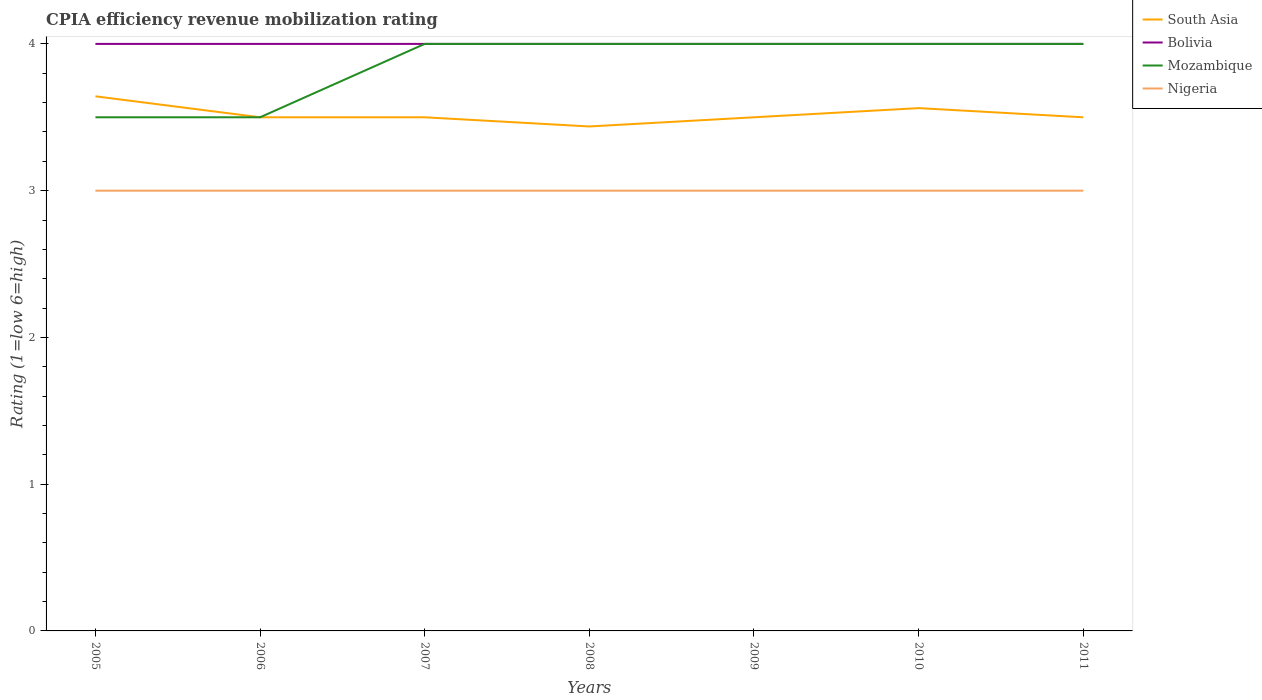How many different coloured lines are there?
Ensure brevity in your answer.  4. Does the line corresponding to Nigeria intersect with the line corresponding to South Asia?
Your answer should be compact. No. Across all years, what is the maximum CPIA rating in South Asia?
Offer a very short reply. 3.44. In which year was the CPIA rating in South Asia maximum?
Offer a very short reply. 2008. What is the total CPIA rating in South Asia in the graph?
Ensure brevity in your answer.  0.08. What is the difference between the highest and the second highest CPIA rating in Bolivia?
Keep it short and to the point. 0. How many lines are there?
Keep it short and to the point. 4. How many years are there in the graph?
Keep it short and to the point. 7. Are the values on the major ticks of Y-axis written in scientific E-notation?
Your answer should be very brief. No. Does the graph contain grids?
Keep it short and to the point. No. Where does the legend appear in the graph?
Provide a short and direct response. Top right. How many legend labels are there?
Give a very brief answer. 4. How are the legend labels stacked?
Give a very brief answer. Vertical. What is the title of the graph?
Ensure brevity in your answer.  CPIA efficiency revenue mobilization rating. What is the label or title of the X-axis?
Offer a very short reply. Years. What is the Rating (1=low 6=high) in South Asia in 2005?
Offer a very short reply. 3.64. What is the Rating (1=low 6=high) of Mozambique in 2005?
Offer a very short reply. 3.5. What is the Rating (1=low 6=high) of Nigeria in 2006?
Ensure brevity in your answer.  3. What is the Rating (1=low 6=high) of Bolivia in 2007?
Offer a very short reply. 4. What is the Rating (1=low 6=high) in Mozambique in 2007?
Make the answer very short. 4. What is the Rating (1=low 6=high) in South Asia in 2008?
Give a very brief answer. 3.44. What is the Rating (1=low 6=high) of Mozambique in 2008?
Offer a terse response. 4. What is the Rating (1=low 6=high) of Nigeria in 2008?
Give a very brief answer. 3. What is the Rating (1=low 6=high) in Bolivia in 2009?
Keep it short and to the point. 4. What is the Rating (1=low 6=high) in Nigeria in 2009?
Offer a terse response. 3. What is the Rating (1=low 6=high) in South Asia in 2010?
Your answer should be compact. 3.56. What is the Rating (1=low 6=high) in Mozambique in 2010?
Provide a short and direct response. 4. What is the Rating (1=low 6=high) of South Asia in 2011?
Give a very brief answer. 3.5. What is the Rating (1=low 6=high) of Bolivia in 2011?
Make the answer very short. 4. What is the Rating (1=low 6=high) of Mozambique in 2011?
Provide a short and direct response. 4. What is the Rating (1=low 6=high) in Nigeria in 2011?
Give a very brief answer. 3. Across all years, what is the maximum Rating (1=low 6=high) of South Asia?
Ensure brevity in your answer.  3.64. Across all years, what is the maximum Rating (1=low 6=high) of Bolivia?
Provide a short and direct response. 4. Across all years, what is the maximum Rating (1=low 6=high) in Mozambique?
Your answer should be very brief. 4. Across all years, what is the minimum Rating (1=low 6=high) of South Asia?
Ensure brevity in your answer.  3.44. Across all years, what is the minimum Rating (1=low 6=high) in Bolivia?
Your answer should be very brief. 4. Across all years, what is the minimum Rating (1=low 6=high) in Mozambique?
Your answer should be compact. 3.5. Across all years, what is the minimum Rating (1=low 6=high) in Nigeria?
Ensure brevity in your answer.  3. What is the total Rating (1=low 6=high) of South Asia in the graph?
Provide a short and direct response. 24.64. What is the difference between the Rating (1=low 6=high) of South Asia in 2005 and that in 2006?
Give a very brief answer. 0.14. What is the difference between the Rating (1=low 6=high) in Nigeria in 2005 and that in 2006?
Ensure brevity in your answer.  0. What is the difference between the Rating (1=low 6=high) of South Asia in 2005 and that in 2007?
Provide a short and direct response. 0.14. What is the difference between the Rating (1=low 6=high) in Mozambique in 2005 and that in 2007?
Your answer should be compact. -0.5. What is the difference between the Rating (1=low 6=high) of South Asia in 2005 and that in 2008?
Your answer should be compact. 0.21. What is the difference between the Rating (1=low 6=high) of Bolivia in 2005 and that in 2008?
Provide a short and direct response. 0. What is the difference between the Rating (1=low 6=high) in Nigeria in 2005 and that in 2008?
Your answer should be very brief. 0. What is the difference between the Rating (1=low 6=high) of South Asia in 2005 and that in 2009?
Give a very brief answer. 0.14. What is the difference between the Rating (1=low 6=high) of Bolivia in 2005 and that in 2009?
Provide a short and direct response. 0. What is the difference between the Rating (1=low 6=high) of South Asia in 2005 and that in 2010?
Offer a very short reply. 0.08. What is the difference between the Rating (1=low 6=high) of Bolivia in 2005 and that in 2010?
Provide a succinct answer. 0. What is the difference between the Rating (1=low 6=high) of Nigeria in 2005 and that in 2010?
Make the answer very short. 0. What is the difference between the Rating (1=low 6=high) in South Asia in 2005 and that in 2011?
Provide a succinct answer. 0.14. What is the difference between the Rating (1=low 6=high) of Bolivia in 2005 and that in 2011?
Make the answer very short. 0. What is the difference between the Rating (1=low 6=high) in Nigeria in 2005 and that in 2011?
Give a very brief answer. 0. What is the difference between the Rating (1=low 6=high) in South Asia in 2006 and that in 2007?
Your response must be concise. 0. What is the difference between the Rating (1=low 6=high) in South Asia in 2006 and that in 2008?
Provide a succinct answer. 0.06. What is the difference between the Rating (1=low 6=high) in Bolivia in 2006 and that in 2008?
Ensure brevity in your answer.  0. What is the difference between the Rating (1=low 6=high) in South Asia in 2006 and that in 2009?
Your response must be concise. 0. What is the difference between the Rating (1=low 6=high) in Bolivia in 2006 and that in 2009?
Give a very brief answer. 0. What is the difference between the Rating (1=low 6=high) in Nigeria in 2006 and that in 2009?
Your response must be concise. 0. What is the difference between the Rating (1=low 6=high) of South Asia in 2006 and that in 2010?
Your answer should be compact. -0.06. What is the difference between the Rating (1=low 6=high) of Mozambique in 2006 and that in 2010?
Provide a short and direct response. -0.5. What is the difference between the Rating (1=low 6=high) in South Asia in 2006 and that in 2011?
Ensure brevity in your answer.  0. What is the difference between the Rating (1=low 6=high) in Nigeria in 2006 and that in 2011?
Keep it short and to the point. 0. What is the difference between the Rating (1=low 6=high) of South Asia in 2007 and that in 2008?
Make the answer very short. 0.06. What is the difference between the Rating (1=low 6=high) in Nigeria in 2007 and that in 2008?
Make the answer very short. 0. What is the difference between the Rating (1=low 6=high) of South Asia in 2007 and that in 2009?
Offer a very short reply. 0. What is the difference between the Rating (1=low 6=high) in Bolivia in 2007 and that in 2009?
Your answer should be very brief. 0. What is the difference between the Rating (1=low 6=high) of Nigeria in 2007 and that in 2009?
Your answer should be compact. 0. What is the difference between the Rating (1=low 6=high) of South Asia in 2007 and that in 2010?
Ensure brevity in your answer.  -0.06. What is the difference between the Rating (1=low 6=high) in Mozambique in 2007 and that in 2010?
Your response must be concise. 0. What is the difference between the Rating (1=low 6=high) of Nigeria in 2007 and that in 2010?
Your answer should be very brief. 0. What is the difference between the Rating (1=low 6=high) in Bolivia in 2007 and that in 2011?
Ensure brevity in your answer.  0. What is the difference between the Rating (1=low 6=high) of South Asia in 2008 and that in 2009?
Make the answer very short. -0.06. What is the difference between the Rating (1=low 6=high) in Bolivia in 2008 and that in 2009?
Provide a short and direct response. 0. What is the difference between the Rating (1=low 6=high) in Nigeria in 2008 and that in 2009?
Your answer should be very brief. 0. What is the difference between the Rating (1=low 6=high) of South Asia in 2008 and that in 2010?
Give a very brief answer. -0.12. What is the difference between the Rating (1=low 6=high) in Bolivia in 2008 and that in 2010?
Provide a short and direct response. 0. What is the difference between the Rating (1=low 6=high) of Mozambique in 2008 and that in 2010?
Give a very brief answer. 0. What is the difference between the Rating (1=low 6=high) of Nigeria in 2008 and that in 2010?
Your response must be concise. 0. What is the difference between the Rating (1=low 6=high) in South Asia in 2008 and that in 2011?
Your answer should be very brief. -0.06. What is the difference between the Rating (1=low 6=high) in Nigeria in 2008 and that in 2011?
Make the answer very short. 0. What is the difference between the Rating (1=low 6=high) in South Asia in 2009 and that in 2010?
Provide a short and direct response. -0.06. What is the difference between the Rating (1=low 6=high) of Mozambique in 2009 and that in 2010?
Offer a terse response. 0. What is the difference between the Rating (1=low 6=high) in South Asia in 2009 and that in 2011?
Your answer should be compact. 0. What is the difference between the Rating (1=low 6=high) of Bolivia in 2009 and that in 2011?
Offer a terse response. 0. What is the difference between the Rating (1=low 6=high) of Mozambique in 2009 and that in 2011?
Your answer should be very brief. 0. What is the difference between the Rating (1=low 6=high) of Nigeria in 2009 and that in 2011?
Keep it short and to the point. 0. What is the difference between the Rating (1=low 6=high) in South Asia in 2010 and that in 2011?
Offer a very short reply. 0.06. What is the difference between the Rating (1=low 6=high) in Bolivia in 2010 and that in 2011?
Your answer should be very brief. 0. What is the difference between the Rating (1=low 6=high) in Mozambique in 2010 and that in 2011?
Provide a short and direct response. 0. What is the difference between the Rating (1=low 6=high) of Nigeria in 2010 and that in 2011?
Ensure brevity in your answer.  0. What is the difference between the Rating (1=low 6=high) in South Asia in 2005 and the Rating (1=low 6=high) in Bolivia in 2006?
Your answer should be compact. -0.36. What is the difference between the Rating (1=low 6=high) in South Asia in 2005 and the Rating (1=low 6=high) in Mozambique in 2006?
Your answer should be very brief. 0.14. What is the difference between the Rating (1=low 6=high) in South Asia in 2005 and the Rating (1=low 6=high) in Nigeria in 2006?
Provide a succinct answer. 0.64. What is the difference between the Rating (1=low 6=high) of South Asia in 2005 and the Rating (1=low 6=high) of Bolivia in 2007?
Make the answer very short. -0.36. What is the difference between the Rating (1=low 6=high) in South Asia in 2005 and the Rating (1=low 6=high) in Mozambique in 2007?
Provide a short and direct response. -0.36. What is the difference between the Rating (1=low 6=high) of South Asia in 2005 and the Rating (1=low 6=high) of Nigeria in 2007?
Ensure brevity in your answer.  0.64. What is the difference between the Rating (1=low 6=high) of Bolivia in 2005 and the Rating (1=low 6=high) of Mozambique in 2007?
Offer a terse response. 0. What is the difference between the Rating (1=low 6=high) of Mozambique in 2005 and the Rating (1=low 6=high) of Nigeria in 2007?
Offer a very short reply. 0.5. What is the difference between the Rating (1=low 6=high) in South Asia in 2005 and the Rating (1=low 6=high) in Bolivia in 2008?
Make the answer very short. -0.36. What is the difference between the Rating (1=low 6=high) of South Asia in 2005 and the Rating (1=low 6=high) of Mozambique in 2008?
Provide a short and direct response. -0.36. What is the difference between the Rating (1=low 6=high) in South Asia in 2005 and the Rating (1=low 6=high) in Nigeria in 2008?
Keep it short and to the point. 0.64. What is the difference between the Rating (1=low 6=high) of Mozambique in 2005 and the Rating (1=low 6=high) of Nigeria in 2008?
Give a very brief answer. 0.5. What is the difference between the Rating (1=low 6=high) in South Asia in 2005 and the Rating (1=low 6=high) in Bolivia in 2009?
Offer a terse response. -0.36. What is the difference between the Rating (1=low 6=high) in South Asia in 2005 and the Rating (1=low 6=high) in Mozambique in 2009?
Offer a terse response. -0.36. What is the difference between the Rating (1=low 6=high) of South Asia in 2005 and the Rating (1=low 6=high) of Nigeria in 2009?
Provide a succinct answer. 0.64. What is the difference between the Rating (1=low 6=high) of Mozambique in 2005 and the Rating (1=low 6=high) of Nigeria in 2009?
Ensure brevity in your answer.  0.5. What is the difference between the Rating (1=low 6=high) in South Asia in 2005 and the Rating (1=low 6=high) in Bolivia in 2010?
Offer a terse response. -0.36. What is the difference between the Rating (1=low 6=high) in South Asia in 2005 and the Rating (1=low 6=high) in Mozambique in 2010?
Make the answer very short. -0.36. What is the difference between the Rating (1=low 6=high) in South Asia in 2005 and the Rating (1=low 6=high) in Nigeria in 2010?
Give a very brief answer. 0.64. What is the difference between the Rating (1=low 6=high) of South Asia in 2005 and the Rating (1=low 6=high) of Bolivia in 2011?
Make the answer very short. -0.36. What is the difference between the Rating (1=low 6=high) in South Asia in 2005 and the Rating (1=low 6=high) in Mozambique in 2011?
Provide a succinct answer. -0.36. What is the difference between the Rating (1=low 6=high) of South Asia in 2005 and the Rating (1=low 6=high) of Nigeria in 2011?
Your answer should be very brief. 0.64. What is the difference between the Rating (1=low 6=high) in Mozambique in 2005 and the Rating (1=low 6=high) in Nigeria in 2011?
Offer a terse response. 0.5. What is the difference between the Rating (1=low 6=high) in Bolivia in 2006 and the Rating (1=low 6=high) in Mozambique in 2007?
Your answer should be very brief. 0. What is the difference between the Rating (1=low 6=high) of Mozambique in 2006 and the Rating (1=low 6=high) of Nigeria in 2007?
Offer a terse response. 0.5. What is the difference between the Rating (1=low 6=high) of Bolivia in 2006 and the Rating (1=low 6=high) of Mozambique in 2008?
Your response must be concise. 0. What is the difference between the Rating (1=low 6=high) in Bolivia in 2006 and the Rating (1=low 6=high) in Nigeria in 2008?
Keep it short and to the point. 1. What is the difference between the Rating (1=low 6=high) of Mozambique in 2006 and the Rating (1=low 6=high) of Nigeria in 2008?
Your response must be concise. 0.5. What is the difference between the Rating (1=low 6=high) in South Asia in 2006 and the Rating (1=low 6=high) in Nigeria in 2009?
Ensure brevity in your answer.  0.5. What is the difference between the Rating (1=low 6=high) of Bolivia in 2006 and the Rating (1=low 6=high) of Mozambique in 2009?
Provide a succinct answer. 0. What is the difference between the Rating (1=low 6=high) of Mozambique in 2006 and the Rating (1=low 6=high) of Nigeria in 2009?
Offer a terse response. 0.5. What is the difference between the Rating (1=low 6=high) in South Asia in 2006 and the Rating (1=low 6=high) in Mozambique in 2010?
Your answer should be compact. -0.5. What is the difference between the Rating (1=low 6=high) in South Asia in 2006 and the Rating (1=low 6=high) in Nigeria in 2010?
Offer a terse response. 0.5. What is the difference between the Rating (1=low 6=high) in Bolivia in 2006 and the Rating (1=low 6=high) in Nigeria in 2010?
Your answer should be compact. 1. What is the difference between the Rating (1=low 6=high) of South Asia in 2006 and the Rating (1=low 6=high) of Nigeria in 2011?
Keep it short and to the point. 0.5. What is the difference between the Rating (1=low 6=high) in Mozambique in 2006 and the Rating (1=low 6=high) in Nigeria in 2011?
Ensure brevity in your answer.  0.5. What is the difference between the Rating (1=low 6=high) in South Asia in 2007 and the Rating (1=low 6=high) in Bolivia in 2008?
Provide a succinct answer. -0.5. What is the difference between the Rating (1=low 6=high) in South Asia in 2007 and the Rating (1=low 6=high) in Mozambique in 2008?
Give a very brief answer. -0.5. What is the difference between the Rating (1=low 6=high) in South Asia in 2007 and the Rating (1=low 6=high) in Nigeria in 2008?
Provide a succinct answer. 0.5. What is the difference between the Rating (1=low 6=high) in South Asia in 2007 and the Rating (1=low 6=high) in Bolivia in 2009?
Your response must be concise. -0.5. What is the difference between the Rating (1=low 6=high) of South Asia in 2007 and the Rating (1=low 6=high) of Nigeria in 2009?
Offer a very short reply. 0.5. What is the difference between the Rating (1=low 6=high) in Bolivia in 2007 and the Rating (1=low 6=high) in Nigeria in 2009?
Your response must be concise. 1. What is the difference between the Rating (1=low 6=high) in Mozambique in 2007 and the Rating (1=low 6=high) in Nigeria in 2009?
Provide a succinct answer. 1. What is the difference between the Rating (1=low 6=high) of South Asia in 2007 and the Rating (1=low 6=high) of Mozambique in 2010?
Your answer should be very brief. -0.5. What is the difference between the Rating (1=low 6=high) in South Asia in 2007 and the Rating (1=low 6=high) in Nigeria in 2010?
Your response must be concise. 0.5. What is the difference between the Rating (1=low 6=high) in Bolivia in 2007 and the Rating (1=low 6=high) in Mozambique in 2010?
Provide a succinct answer. 0. What is the difference between the Rating (1=low 6=high) of Bolivia in 2007 and the Rating (1=low 6=high) of Nigeria in 2010?
Your answer should be compact. 1. What is the difference between the Rating (1=low 6=high) of South Asia in 2007 and the Rating (1=low 6=high) of Bolivia in 2011?
Your response must be concise. -0.5. What is the difference between the Rating (1=low 6=high) of South Asia in 2007 and the Rating (1=low 6=high) of Mozambique in 2011?
Offer a terse response. -0.5. What is the difference between the Rating (1=low 6=high) of Bolivia in 2007 and the Rating (1=low 6=high) of Nigeria in 2011?
Offer a very short reply. 1. What is the difference between the Rating (1=low 6=high) in Mozambique in 2007 and the Rating (1=low 6=high) in Nigeria in 2011?
Offer a terse response. 1. What is the difference between the Rating (1=low 6=high) in South Asia in 2008 and the Rating (1=low 6=high) in Bolivia in 2009?
Offer a terse response. -0.56. What is the difference between the Rating (1=low 6=high) in South Asia in 2008 and the Rating (1=low 6=high) in Mozambique in 2009?
Make the answer very short. -0.56. What is the difference between the Rating (1=low 6=high) in South Asia in 2008 and the Rating (1=low 6=high) in Nigeria in 2009?
Provide a short and direct response. 0.44. What is the difference between the Rating (1=low 6=high) of Bolivia in 2008 and the Rating (1=low 6=high) of Mozambique in 2009?
Provide a short and direct response. 0. What is the difference between the Rating (1=low 6=high) of Bolivia in 2008 and the Rating (1=low 6=high) of Nigeria in 2009?
Your response must be concise. 1. What is the difference between the Rating (1=low 6=high) in South Asia in 2008 and the Rating (1=low 6=high) in Bolivia in 2010?
Your answer should be compact. -0.56. What is the difference between the Rating (1=low 6=high) of South Asia in 2008 and the Rating (1=low 6=high) of Mozambique in 2010?
Provide a succinct answer. -0.56. What is the difference between the Rating (1=low 6=high) in South Asia in 2008 and the Rating (1=low 6=high) in Nigeria in 2010?
Make the answer very short. 0.44. What is the difference between the Rating (1=low 6=high) in Bolivia in 2008 and the Rating (1=low 6=high) in Mozambique in 2010?
Keep it short and to the point. 0. What is the difference between the Rating (1=low 6=high) of Bolivia in 2008 and the Rating (1=low 6=high) of Nigeria in 2010?
Your answer should be very brief. 1. What is the difference between the Rating (1=low 6=high) of South Asia in 2008 and the Rating (1=low 6=high) of Bolivia in 2011?
Your response must be concise. -0.56. What is the difference between the Rating (1=low 6=high) in South Asia in 2008 and the Rating (1=low 6=high) in Mozambique in 2011?
Give a very brief answer. -0.56. What is the difference between the Rating (1=low 6=high) of South Asia in 2008 and the Rating (1=low 6=high) of Nigeria in 2011?
Offer a very short reply. 0.44. What is the difference between the Rating (1=low 6=high) in Bolivia in 2008 and the Rating (1=low 6=high) in Mozambique in 2011?
Offer a very short reply. 0. What is the difference between the Rating (1=low 6=high) of Bolivia in 2008 and the Rating (1=low 6=high) of Nigeria in 2011?
Offer a terse response. 1. What is the difference between the Rating (1=low 6=high) of Bolivia in 2009 and the Rating (1=low 6=high) of Nigeria in 2010?
Your answer should be very brief. 1. What is the difference between the Rating (1=low 6=high) in Mozambique in 2009 and the Rating (1=low 6=high) in Nigeria in 2010?
Ensure brevity in your answer.  1. What is the difference between the Rating (1=low 6=high) of South Asia in 2009 and the Rating (1=low 6=high) of Bolivia in 2011?
Your answer should be very brief. -0.5. What is the difference between the Rating (1=low 6=high) of Bolivia in 2009 and the Rating (1=low 6=high) of Mozambique in 2011?
Your answer should be compact. 0. What is the difference between the Rating (1=low 6=high) of Bolivia in 2009 and the Rating (1=low 6=high) of Nigeria in 2011?
Your answer should be very brief. 1. What is the difference between the Rating (1=low 6=high) of South Asia in 2010 and the Rating (1=low 6=high) of Bolivia in 2011?
Make the answer very short. -0.44. What is the difference between the Rating (1=low 6=high) in South Asia in 2010 and the Rating (1=low 6=high) in Mozambique in 2011?
Offer a very short reply. -0.44. What is the difference between the Rating (1=low 6=high) in South Asia in 2010 and the Rating (1=low 6=high) in Nigeria in 2011?
Offer a terse response. 0.56. What is the difference between the Rating (1=low 6=high) in Bolivia in 2010 and the Rating (1=low 6=high) in Nigeria in 2011?
Provide a succinct answer. 1. What is the difference between the Rating (1=low 6=high) of Mozambique in 2010 and the Rating (1=low 6=high) of Nigeria in 2011?
Offer a terse response. 1. What is the average Rating (1=low 6=high) in South Asia per year?
Your answer should be very brief. 3.52. What is the average Rating (1=low 6=high) of Bolivia per year?
Keep it short and to the point. 4. What is the average Rating (1=low 6=high) of Mozambique per year?
Provide a short and direct response. 3.86. In the year 2005, what is the difference between the Rating (1=low 6=high) in South Asia and Rating (1=low 6=high) in Bolivia?
Provide a succinct answer. -0.36. In the year 2005, what is the difference between the Rating (1=low 6=high) of South Asia and Rating (1=low 6=high) of Mozambique?
Offer a terse response. 0.14. In the year 2005, what is the difference between the Rating (1=low 6=high) in South Asia and Rating (1=low 6=high) in Nigeria?
Offer a very short reply. 0.64. In the year 2005, what is the difference between the Rating (1=low 6=high) in Bolivia and Rating (1=low 6=high) in Nigeria?
Make the answer very short. 1. In the year 2006, what is the difference between the Rating (1=low 6=high) in South Asia and Rating (1=low 6=high) in Bolivia?
Your answer should be compact. -0.5. In the year 2006, what is the difference between the Rating (1=low 6=high) of South Asia and Rating (1=low 6=high) of Mozambique?
Make the answer very short. 0. In the year 2006, what is the difference between the Rating (1=low 6=high) in Bolivia and Rating (1=low 6=high) in Nigeria?
Make the answer very short. 1. In the year 2007, what is the difference between the Rating (1=low 6=high) in South Asia and Rating (1=low 6=high) in Bolivia?
Offer a very short reply. -0.5. In the year 2007, what is the difference between the Rating (1=low 6=high) of South Asia and Rating (1=low 6=high) of Mozambique?
Your answer should be compact. -0.5. In the year 2007, what is the difference between the Rating (1=low 6=high) in South Asia and Rating (1=low 6=high) in Nigeria?
Keep it short and to the point. 0.5. In the year 2007, what is the difference between the Rating (1=low 6=high) of Bolivia and Rating (1=low 6=high) of Mozambique?
Offer a very short reply. 0. In the year 2007, what is the difference between the Rating (1=low 6=high) of Mozambique and Rating (1=low 6=high) of Nigeria?
Provide a succinct answer. 1. In the year 2008, what is the difference between the Rating (1=low 6=high) in South Asia and Rating (1=low 6=high) in Bolivia?
Your answer should be very brief. -0.56. In the year 2008, what is the difference between the Rating (1=low 6=high) of South Asia and Rating (1=low 6=high) of Mozambique?
Make the answer very short. -0.56. In the year 2008, what is the difference between the Rating (1=low 6=high) of South Asia and Rating (1=low 6=high) of Nigeria?
Keep it short and to the point. 0.44. In the year 2008, what is the difference between the Rating (1=low 6=high) in Mozambique and Rating (1=low 6=high) in Nigeria?
Your answer should be compact. 1. In the year 2009, what is the difference between the Rating (1=low 6=high) of South Asia and Rating (1=low 6=high) of Bolivia?
Keep it short and to the point. -0.5. In the year 2009, what is the difference between the Rating (1=low 6=high) in Bolivia and Rating (1=low 6=high) in Mozambique?
Ensure brevity in your answer.  0. In the year 2010, what is the difference between the Rating (1=low 6=high) of South Asia and Rating (1=low 6=high) of Bolivia?
Give a very brief answer. -0.44. In the year 2010, what is the difference between the Rating (1=low 6=high) in South Asia and Rating (1=low 6=high) in Mozambique?
Make the answer very short. -0.44. In the year 2010, what is the difference between the Rating (1=low 6=high) in South Asia and Rating (1=low 6=high) in Nigeria?
Provide a short and direct response. 0.56. In the year 2010, what is the difference between the Rating (1=low 6=high) in Bolivia and Rating (1=low 6=high) in Mozambique?
Keep it short and to the point. 0. In the year 2011, what is the difference between the Rating (1=low 6=high) of South Asia and Rating (1=low 6=high) of Mozambique?
Provide a succinct answer. -0.5. In the year 2011, what is the difference between the Rating (1=low 6=high) of South Asia and Rating (1=low 6=high) of Nigeria?
Give a very brief answer. 0.5. In the year 2011, what is the difference between the Rating (1=low 6=high) in Bolivia and Rating (1=low 6=high) in Mozambique?
Keep it short and to the point. 0. In the year 2011, what is the difference between the Rating (1=low 6=high) of Bolivia and Rating (1=low 6=high) of Nigeria?
Make the answer very short. 1. In the year 2011, what is the difference between the Rating (1=low 6=high) of Mozambique and Rating (1=low 6=high) of Nigeria?
Make the answer very short. 1. What is the ratio of the Rating (1=low 6=high) of South Asia in 2005 to that in 2006?
Keep it short and to the point. 1.04. What is the ratio of the Rating (1=low 6=high) of Bolivia in 2005 to that in 2006?
Ensure brevity in your answer.  1. What is the ratio of the Rating (1=low 6=high) of South Asia in 2005 to that in 2007?
Provide a succinct answer. 1.04. What is the ratio of the Rating (1=low 6=high) in Mozambique in 2005 to that in 2007?
Provide a succinct answer. 0.88. What is the ratio of the Rating (1=low 6=high) of South Asia in 2005 to that in 2008?
Your answer should be compact. 1.06. What is the ratio of the Rating (1=low 6=high) in Bolivia in 2005 to that in 2008?
Keep it short and to the point. 1. What is the ratio of the Rating (1=low 6=high) in South Asia in 2005 to that in 2009?
Provide a succinct answer. 1.04. What is the ratio of the Rating (1=low 6=high) of Mozambique in 2005 to that in 2009?
Provide a short and direct response. 0.88. What is the ratio of the Rating (1=low 6=high) in Nigeria in 2005 to that in 2009?
Keep it short and to the point. 1. What is the ratio of the Rating (1=low 6=high) of South Asia in 2005 to that in 2010?
Make the answer very short. 1.02. What is the ratio of the Rating (1=low 6=high) of Bolivia in 2005 to that in 2010?
Ensure brevity in your answer.  1. What is the ratio of the Rating (1=low 6=high) of Mozambique in 2005 to that in 2010?
Ensure brevity in your answer.  0.88. What is the ratio of the Rating (1=low 6=high) of South Asia in 2005 to that in 2011?
Ensure brevity in your answer.  1.04. What is the ratio of the Rating (1=low 6=high) in Bolivia in 2005 to that in 2011?
Offer a very short reply. 1. What is the ratio of the Rating (1=low 6=high) of Mozambique in 2005 to that in 2011?
Your answer should be compact. 0.88. What is the ratio of the Rating (1=low 6=high) of Bolivia in 2006 to that in 2007?
Offer a terse response. 1. What is the ratio of the Rating (1=low 6=high) of South Asia in 2006 to that in 2008?
Your response must be concise. 1.02. What is the ratio of the Rating (1=low 6=high) of Nigeria in 2006 to that in 2008?
Provide a short and direct response. 1. What is the ratio of the Rating (1=low 6=high) of South Asia in 2006 to that in 2009?
Your answer should be very brief. 1. What is the ratio of the Rating (1=low 6=high) of Bolivia in 2006 to that in 2009?
Keep it short and to the point. 1. What is the ratio of the Rating (1=low 6=high) in Nigeria in 2006 to that in 2009?
Give a very brief answer. 1. What is the ratio of the Rating (1=low 6=high) of South Asia in 2006 to that in 2010?
Offer a very short reply. 0.98. What is the ratio of the Rating (1=low 6=high) in Bolivia in 2006 to that in 2010?
Ensure brevity in your answer.  1. What is the ratio of the Rating (1=low 6=high) of Mozambique in 2006 to that in 2010?
Ensure brevity in your answer.  0.88. What is the ratio of the Rating (1=low 6=high) in Nigeria in 2006 to that in 2010?
Provide a short and direct response. 1. What is the ratio of the Rating (1=low 6=high) of South Asia in 2007 to that in 2008?
Ensure brevity in your answer.  1.02. What is the ratio of the Rating (1=low 6=high) of Bolivia in 2007 to that in 2008?
Provide a short and direct response. 1. What is the ratio of the Rating (1=low 6=high) of Nigeria in 2007 to that in 2008?
Your answer should be compact. 1. What is the ratio of the Rating (1=low 6=high) in South Asia in 2007 to that in 2009?
Your answer should be compact. 1. What is the ratio of the Rating (1=low 6=high) of Bolivia in 2007 to that in 2009?
Make the answer very short. 1. What is the ratio of the Rating (1=low 6=high) of Mozambique in 2007 to that in 2009?
Ensure brevity in your answer.  1. What is the ratio of the Rating (1=low 6=high) of Nigeria in 2007 to that in 2009?
Ensure brevity in your answer.  1. What is the ratio of the Rating (1=low 6=high) of South Asia in 2007 to that in 2010?
Provide a short and direct response. 0.98. What is the ratio of the Rating (1=low 6=high) in Bolivia in 2007 to that in 2010?
Give a very brief answer. 1. What is the ratio of the Rating (1=low 6=high) in South Asia in 2007 to that in 2011?
Your answer should be very brief. 1. What is the ratio of the Rating (1=low 6=high) of Bolivia in 2007 to that in 2011?
Ensure brevity in your answer.  1. What is the ratio of the Rating (1=low 6=high) of Nigeria in 2007 to that in 2011?
Offer a very short reply. 1. What is the ratio of the Rating (1=low 6=high) in South Asia in 2008 to that in 2009?
Provide a succinct answer. 0.98. What is the ratio of the Rating (1=low 6=high) of Mozambique in 2008 to that in 2009?
Give a very brief answer. 1. What is the ratio of the Rating (1=low 6=high) of South Asia in 2008 to that in 2010?
Give a very brief answer. 0.96. What is the ratio of the Rating (1=low 6=high) in Bolivia in 2008 to that in 2010?
Make the answer very short. 1. What is the ratio of the Rating (1=low 6=high) of South Asia in 2008 to that in 2011?
Offer a very short reply. 0.98. What is the ratio of the Rating (1=low 6=high) of Nigeria in 2008 to that in 2011?
Offer a terse response. 1. What is the ratio of the Rating (1=low 6=high) of South Asia in 2009 to that in 2010?
Give a very brief answer. 0.98. What is the ratio of the Rating (1=low 6=high) in Bolivia in 2009 to that in 2010?
Ensure brevity in your answer.  1. What is the ratio of the Rating (1=low 6=high) in Nigeria in 2009 to that in 2011?
Your response must be concise. 1. What is the ratio of the Rating (1=low 6=high) of South Asia in 2010 to that in 2011?
Offer a very short reply. 1.02. What is the ratio of the Rating (1=low 6=high) of Nigeria in 2010 to that in 2011?
Your response must be concise. 1. What is the difference between the highest and the second highest Rating (1=low 6=high) in South Asia?
Your answer should be compact. 0.08. What is the difference between the highest and the second highest Rating (1=low 6=high) in Nigeria?
Keep it short and to the point. 0. What is the difference between the highest and the lowest Rating (1=low 6=high) in South Asia?
Your answer should be compact. 0.21. What is the difference between the highest and the lowest Rating (1=low 6=high) in Bolivia?
Your answer should be very brief. 0. What is the difference between the highest and the lowest Rating (1=low 6=high) of Mozambique?
Ensure brevity in your answer.  0.5. 